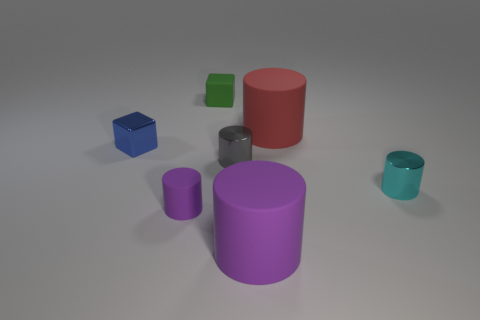Add 2 tiny green things. How many objects exist? 9 Subtract all cubes. How many objects are left? 5 Add 2 metallic cylinders. How many metallic cylinders are left? 4 Add 7 cyan metallic objects. How many cyan metallic objects exist? 8 Subtract 0 brown cubes. How many objects are left? 7 Subtract all large gray shiny things. Subtract all tiny cyan shiny objects. How many objects are left? 6 